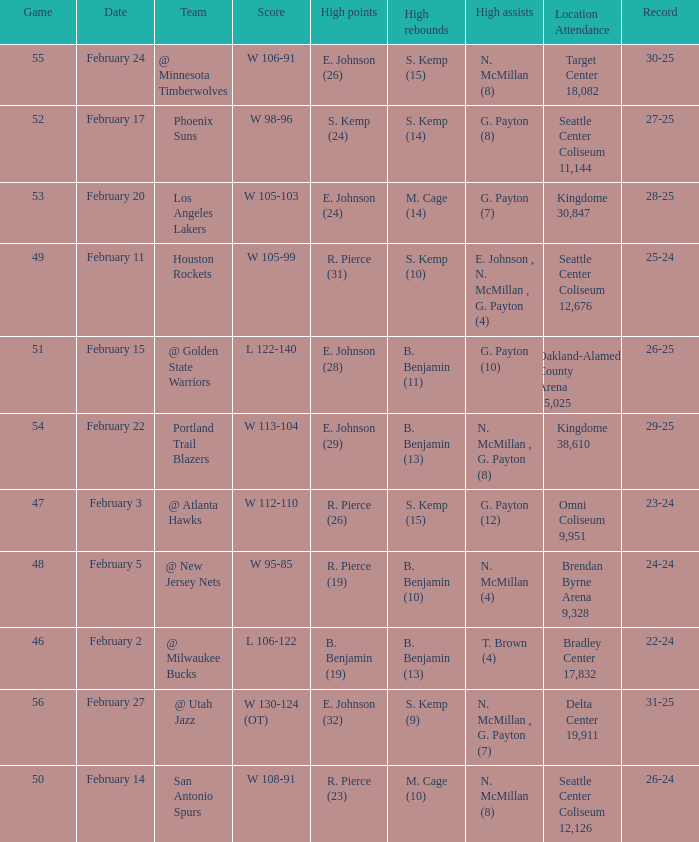What date was the game played in seattle center coliseum 12,126? February 14. 